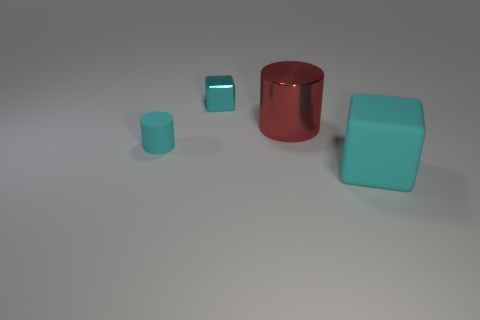Add 2 big purple cylinders. How many objects exist? 6 Subtract 0 gray blocks. How many objects are left? 4 Subtract all big metallic objects. Subtract all cyan metallic blocks. How many objects are left? 2 Add 4 metal blocks. How many metal blocks are left? 5 Add 1 shiny cylinders. How many shiny cylinders exist? 2 